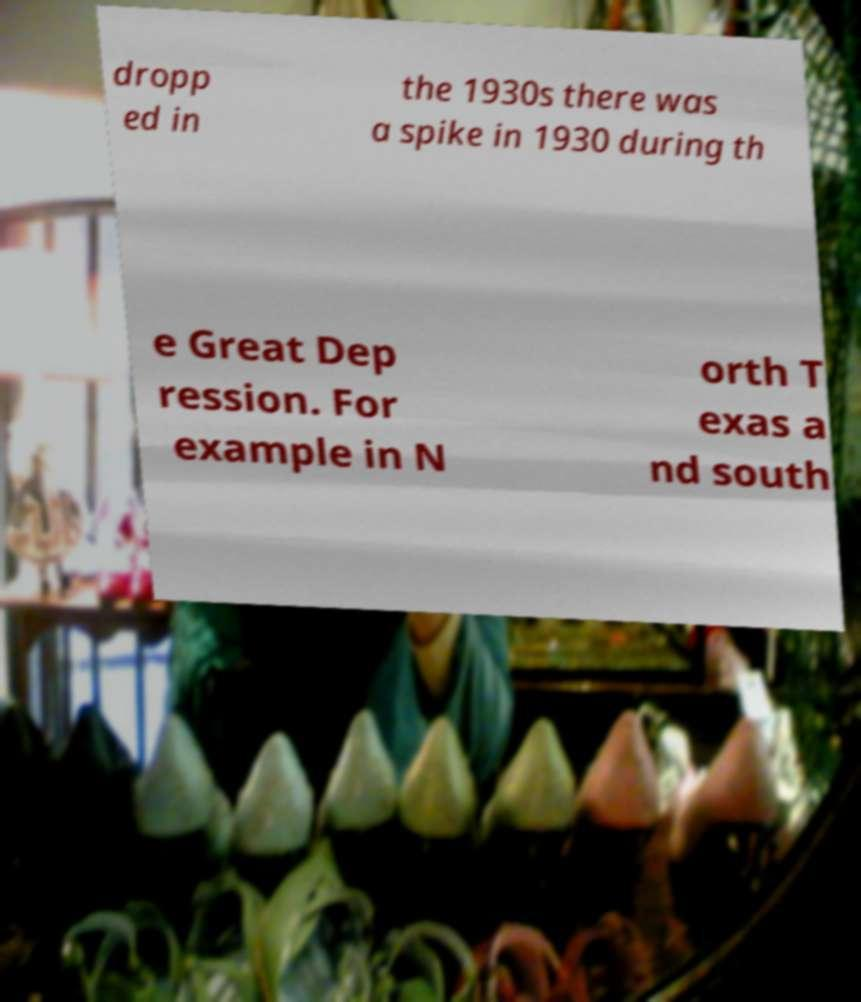Can you read and provide the text displayed in the image?This photo seems to have some interesting text. Can you extract and type it out for me? dropp ed in the 1930s there was a spike in 1930 during th e Great Dep ression. For example in N orth T exas a nd south 